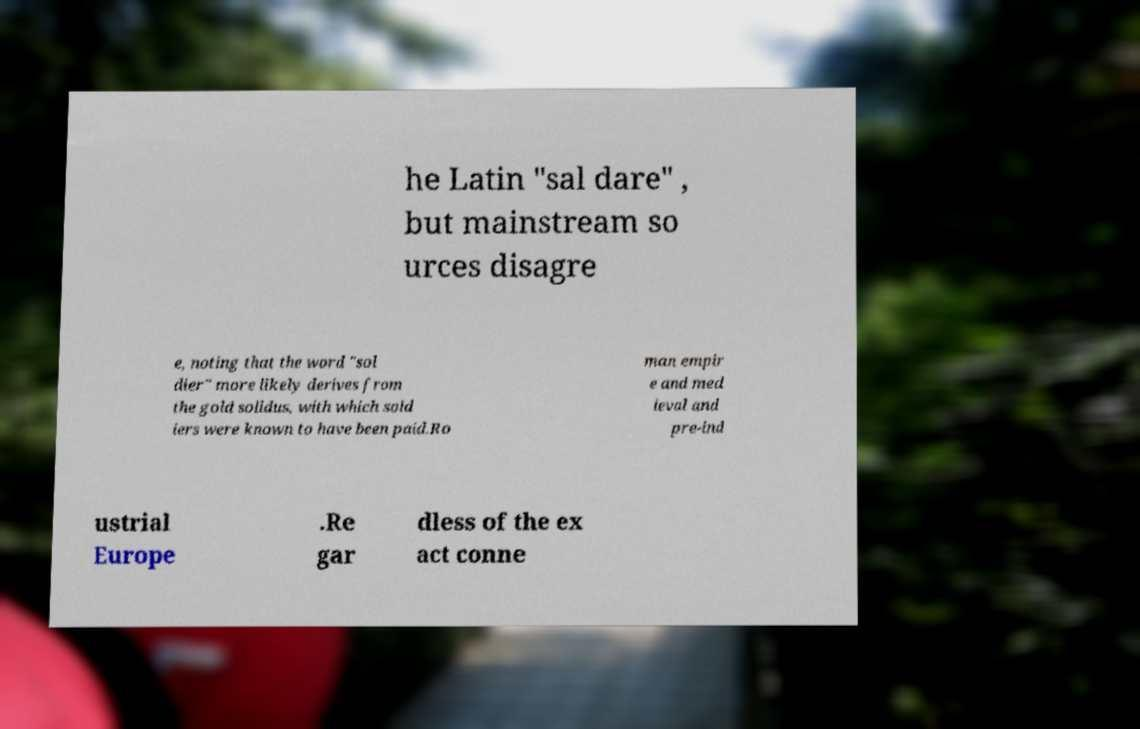I need the written content from this picture converted into text. Can you do that? he Latin "sal dare" , but mainstream so urces disagre e, noting that the word "sol dier" more likely derives from the gold solidus, with which sold iers were known to have been paid.Ro man empir e and med ieval and pre-ind ustrial Europe .Re gar dless of the ex act conne 